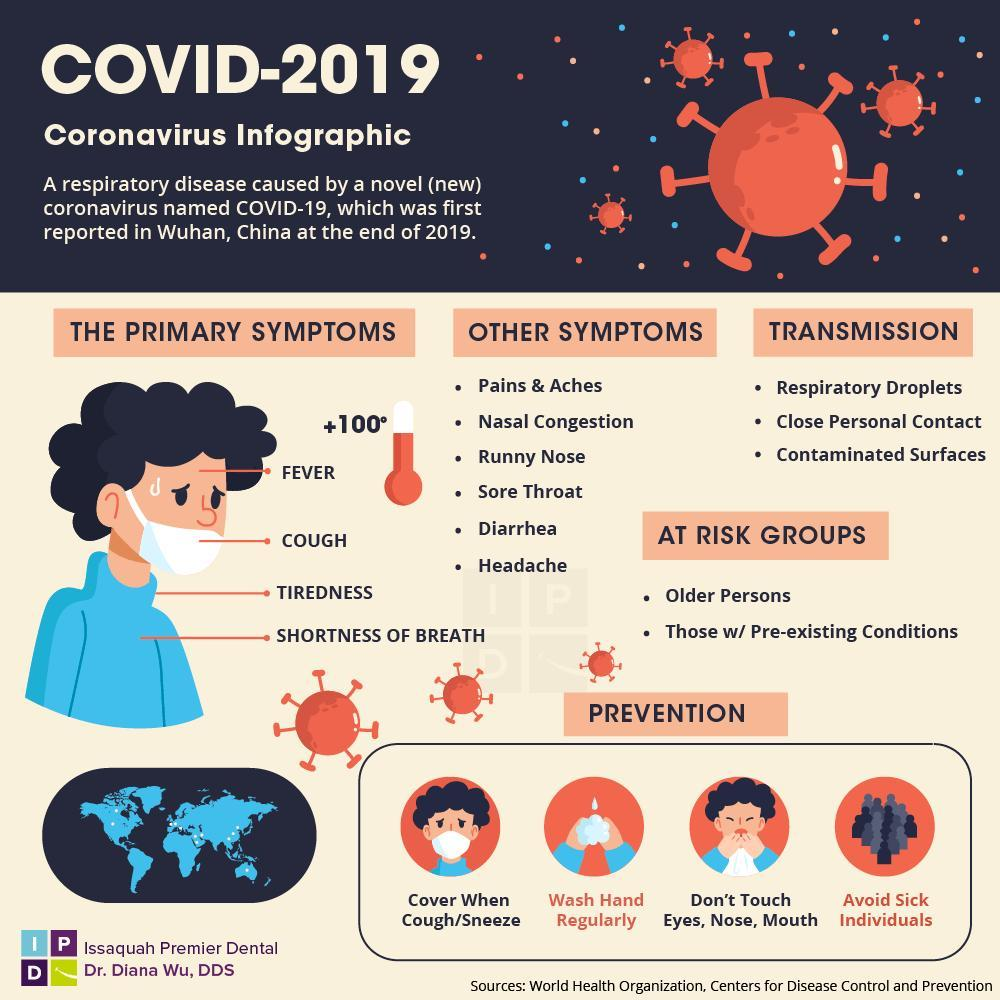What is the correct procedure to be done when people cough or sneeze?
Answer the question with a short phrase. cover when cough/sneeze Which category of people are at more risk for corona? Older persons, those w/ Pre-existing Conditions In how many different ways a person can be affected with Corona? 3 What is the average body temperature of corona affected person in degree Celsius? +100 Which are the body parts that you should not touch ? Eyes, Nose, Mouth How many prevention methods are shown in red color? 2 